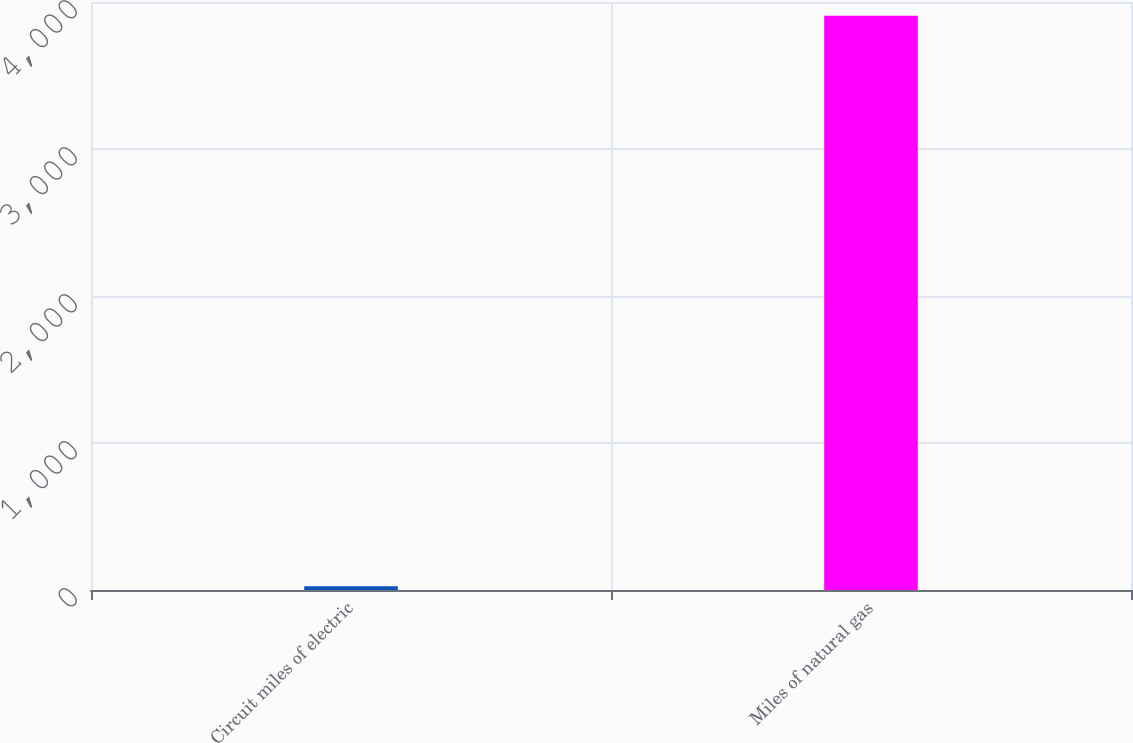<chart> <loc_0><loc_0><loc_500><loc_500><bar_chart><fcel>Circuit miles of electric<fcel>Miles of natural gas<nl><fcel>25<fcel>3907<nl></chart> 